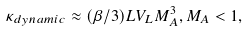<formula> <loc_0><loc_0><loc_500><loc_500>\kappa _ { d y n a m i c } \approx ( \beta / 3 ) L V _ { L } M _ { A } ^ { 3 } , M _ { A } < 1 ,</formula> 